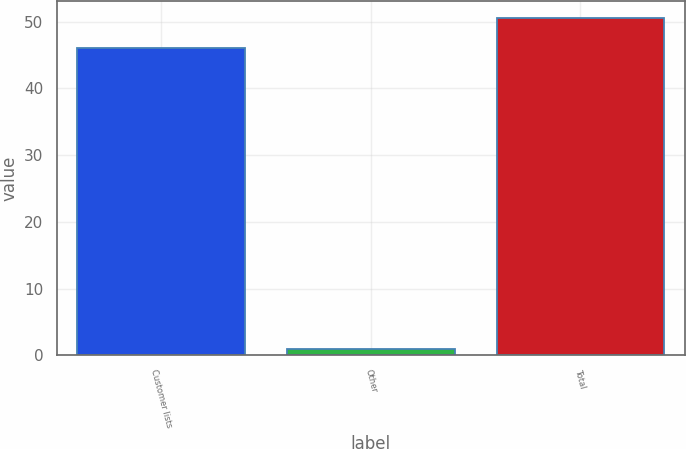Convert chart to OTSL. <chart><loc_0><loc_0><loc_500><loc_500><bar_chart><fcel>Customer lists<fcel>Other<fcel>Total<nl><fcel>46<fcel>1<fcel>50.6<nl></chart> 